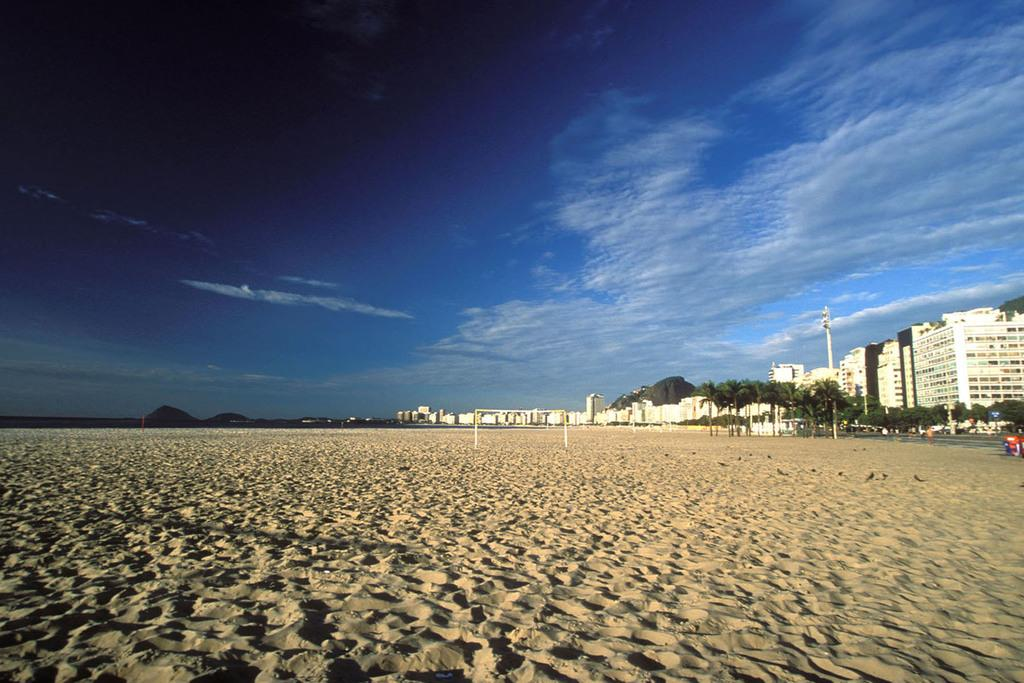What type of terrain is visible in the image? There is sand in the image. What structures can be seen on the right side of the image? There are buildings on the right side of the image. What type of vegetation is present in the image? There are trees in the image. What are the poles used for in the image? The purpose of the poles is not specified in the image. What is visible in the background of the image? The sky is visible in the background of the image. What can be seen in the sky? Clouds are present in the sky. How many snakes are slithering around the poles in the image? There are no snakes present in the image. What time is displayed on the clocks in the image? There are no clocks present in the image. 